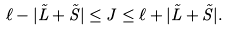Convert formula to latex. <formula><loc_0><loc_0><loc_500><loc_500>\ell - | \vec { L } + \vec { S } | \leq J \leq \ell + | \vec { L } + \vec { S } | .</formula> 